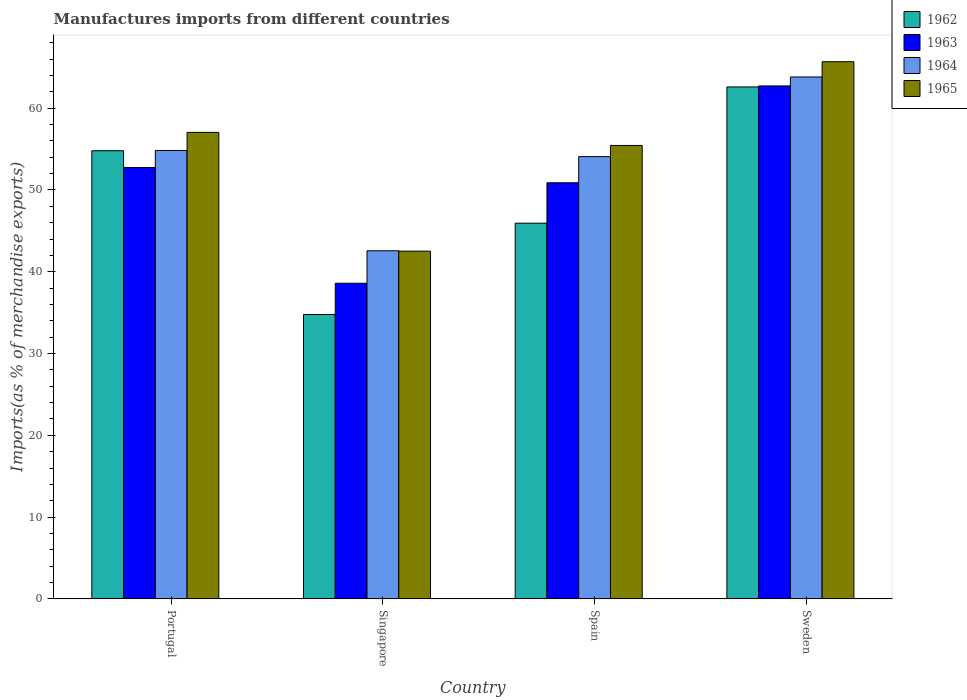How many bars are there on the 2nd tick from the left?
Make the answer very short. 4. How many bars are there on the 4th tick from the right?
Your answer should be very brief. 4. What is the label of the 4th group of bars from the left?
Your response must be concise. Sweden. What is the percentage of imports to different countries in 1965 in Spain?
Offer a very short reply. 55.44. Across all countries, what is the maximum percentage of imports to different countries in 1964?
Your answer should be compact. 63.82. Across all countries, what is the minimum percentage of imports to different countries in 1962?
Your answer should be compact. 34.77. In which country was the percentage of imports to different countries in 1963 minimum?
Make the answer very short. Singapore. What is the total percentage of imports to different countries in 1963 in the graph?
Make the answer very short. 204.95. What is the difference between the percentage of imports to different countries in 1964 in Portugal and that in Sweden?
Ensure brevity in your answer.  -8.99. What is the difference between the percentage of imports to different countries in 1963 in Singapore and the percentage of imports to different countries in 1962 in Spain?
Provide a short and direct response. -7.34. What is the average percentage of imports to different countries in 1962 per country?
Make the answer very short. 49.53. What is the difference between the percentage of imports to different countries of/in 1965 and percentage of imports to different countries of/in 1964 in Singapore?
Ensure brevity in your answer.  -0.04. In how many countries, is the percentage of imports to different countries in 1964 greater than 36 %?
Offer a terse response. 4. What is the ratio of the percentage of imports to different countries in 1963 in Singapore to that in Sweden?
Keep it short and to the point. 0.62. What is the difference between the highest and the second highest percentage of imports to different countries in 1962?
Provide a short and direct response. 8.86. What is the difference between the highest and the lowest percentage of imports to different countries in 1962?
Provide a short and direct response. 27.83. In how many countries, is the percentage of imports to different countries in 1964 greater than the average percentage of imports to different countries in 1964 taken over all countries?
Your response must be concise. 3. What does the 2nd bar from the left in Spain represents?
Offer a terse response. 1963. What does the 4th bar from the right in Singapore represents?
Provide a short and direct response. 1962. Is it the case that in every country, the sum of the percentage of imports to different countries in 1965 and percentage of imports to different countries in 1962 is greater than the percentage of imports to different countries in 1964?
Make the answer very short. Yes. How many bars are there?
Provide a short and direct response. 16. How many countries are there in the graph?
Keep it short and to the point. 4. Where does the legend appear in the graph?
Your response must be concise. Top right. How are the legend labels stacked?
Provide a succinct answer. Vertical. What is the title of the graph?
Provide a succinct answer. Manufactures imports from different countries. Does "1993" appear as one of the legend labels in the graph?
Your answer should be very brief. No. What is the label or title of the X-axis?
Keep it short and to the point. Country. What is the label or title of the Y-axis?
Make the answer very short. Imports(as % of merchandise exports). What is the Imports(as % of merchandise exports) in 1962 in Portugal?
Give a very brief answer. 54.8. What is the Imports(as % of merchandise exports) of 1963 in Portugal?
Offer a terse response. 52.75. What is the Imports(as % of merchandise exports) of 1964 in Portugal?
Make the answer very short. 54.83. What is the Imports(as % of merchandise exports) of 1965 in Portugal?
Give a very brief answer. 57.04. What is the Imports(as % of merchandise exports) in 1962 in Singapore?
Make the answer very short. 34.77. What is the Imports(as % of merchandise exports) in 1963 in Singapore?
Keep it short and to the point. 38.6. What is the Imports(as % of merchandise exports) of 1964 in Singapore?
Provide a short and direct response. 42.56. What is the Imports(as % of merchandise exports) in 1965 in Singapore?
Make the answer very short. 42.52. What is the Imports(as % of merchandise exports) of 1962 in Spain?
Provide a succinct answer. 45.94. What is the Imports(as % of merchandise exports) of 1963 in Spain?
Provide a short and direct response. 50.88. What is the Imports(as % of merchandise exports) in 1964 in Spain?
Give a very brief answer. 54.08. What is the Imports(as % of merchandise exports) in 1965 in Spain?
Offer a very short reply. 55.44. What is the Imports(as % of merchandise exports) in 1962 in Sweden?
Your answer should be compact. 62.6. What is the Imports(as % of merchandise exports) in 1963 in Sweden?
Provide a short and direct response. 62.72. What is the Imports(as % of merchandise exports) in 1964 in Sweden?
Your response must be concise. 63.82. What is the Imports(as % of merchandise exports) in 1965 in Sweden?
Your answer should be compact. 65.68. Across all countries, what is the maximum Imports(as % of merchandise exports) of 1962?
Your answer should be very brief. 62.6. Across all countries, what is the maximum Imports(as % of merchandise exports) in 1963?
Offer a very short reply. 62.72. Across all countries, what is the maximum Imports(as % of merchandise exports) in 1964?
Your response must be concise. 63.82. Across all countries, what is the maximum Imports(as % of merchandise exports) of 1965?
Ensure brevity in your answer.  65.68. Across all countries, what is the minimum Imports(as % of merchandise exports) of 1962?
Ensure brevity in your answer.  34.77. Across all countries, what is the minimum Imports(as % of merchandise exports) of 1963?
Your response must be concise. 38.6. Across all countries, what is the minimum Imports(as % of merchandise exports) of 1964?
Ensure brevity in your answer.  42.56. Across all countries, what is the minimum Imports(as % of merchandise exports) in 1965?
Give a very brief answer. 42.52. What is the total Imports(as % of merchandise exports) of 1962 in the graph?
Keep it short and to the point. 198.11. What is the total Imports(as % of merchandise exports) in 1963 in the graph?
Your answer should be compact. 204.95. What is the total Imports(as % of merchandise exports) of 1964 in the graph?
Offer a very short reply. 215.29. What is the total Imports(as % of merchandise exports) of 1965 in the graph?
Give a very brief answer. 220.69. What is the difference between the Imports(as % of merchandise exports) in 1962 in Portugal and that in Singapore?
Your response must be concise. 20.03. What is the difference between the Imports(as % of merchandise exports) of 1963 in Portugal and that in Singapore?
Provide a short and direct response. 14.16. What is the difference between the Imports(as % of merchandise exports) in 1964 in Portugal and that in Singapore?
Make the answer very short. 12.27. What is the difference between the Imports(as % of merchandise exports) in 1965 in Portugal and that in Singapore?
Your response must be concise. 14.52. What is the difference between the Imports(as % of merchandise exports) of 1962 in Portugal and that in Spain?
Provide a short and direct response. 8.86. What is the difference between the Imports(as % of merchandise exports) in 1963 in Portugal and that in Spain?
Give a very brief answer. 1.87. What is the difference between the Imports(as % of merchandise exports) in 1964 in Portugal and that in Spain?
Your answer should be very brief. 0.75. What is the difference between the Imports(as % of merchandise exports) in 1965 in Portugal and that in Spain?
Give a very brief answer. 1.6. What is the difference between the Imports(as % of merchandise exports) in 1962 in Portugal and that in Sweden?
Provide a succinct answer. -7.8. What is the difference between the Imports(as % of merchandise exports) in 1963 in Portugal and that in Sweden?
Ensure brevity in your answer.  -9.97. What is the difference between the Imports(as % of merchandise exports) in 1964 in Portugal and that in Sweden?
Your response must be concise. -8.99. What is the difference between the Imports(as % of merchandise exports) of 1965 in Portugal and that in Sweden?
Your answer should be very brief. -8.64. What is the difference between the Imports(as % of merchandise exports) of 1962 in Singapore and that in Spain?
Provide a short and direct response. -11.17. What is the difference between the Imports(as % of merchandise exports) in 1963 in Singapore and that in Spain?
Offer a terse response. -12.29. What is the difference between the Imports(as % of merchandise exports) of 1964 in Singapore and that in Spain?
Your response must be concise. -11.51. What is the difference between the Imports(as % of merchandise exports) of 1965 in Singapore and that in Spain?
Offer a terse response. -12.92. What is the difference between the Imports(as % of merchandise exports) in 1962 in Singapore and that in Sweden?
Keep it short and to the point. -27.83. What is the difference between the Imports(as % of merchandise exports) in 1963 in Singapore and that in Sweden?
Offer a very short reply. -24.13. What is the difference between the Imports(as % of merchandise exports) of 1964 in Singapore and that in Sweden?
Offer a very short reply. -21.25. What is the difference between the Imports(as % of merchandise exports) in 1965 in Singapore and that in Sweden?
Provide a succinct answer. -23.16. What is the difference between the Imports(as % of merchandise exports) in 1962 in Spain and that in Sweden?
Give a very brief answer. -16.66. What is the difference between the Imports(as % of merchandise exports) in 1963 in Spain and that in Sweden?
Provide a short and direct response. -11.84. What is the difference between the Imports(as % of merchandise exports) of 1964 in Spain and that in Sweden?
Offer a very short reply. -9.74. What is the difference between the Imports(as % of merchandise exports) in 1965 in Spain and that in Sweden?
Your answer should be compact. -10.24. What is the difference between the Imports(as % of merchandise exports) in 1962 in Portugal and the Imports(as % of merchandise exports) in 1963 in Singapore?
Offer a very short reply. 16.2. What is the difference between the Imports(as % of merchandise exports) in 1962 in Portugal and the Imports(as % of merchandise exports) in 1964 in Singapore?
Provide a succinct answer. 12.23. What is the difference between the Imports(as % of merchandise exports) of 1962 in Portugal and the Imports(as % of merchandise exports) of 1965 in Singapore?
Provide a succinct answer. 12.28. What is the difference between the Imports(as % of merchandise exports) of 1963 in Portugal and the Imports(as % of merchandise exports) of 1964 in Singapore?
Provide a succinct answer. 10.19. What is the difference between the Imports(as % of merchandise exports) in 1963 in Portugal and the Imports(as % of merchandise exports) in 1965 in Singapore?
Offer a very short reply. 10.23. What is the difference between the Imports(as % of merchandise exports) in 1964 in Portugal and the Imports(as % of merchandise exports) in 1965 in Singapore?
Offer a very short reply. 12.31. What is the difference between the Imports(as % of merchandise exports) of 1962 in Portugal and the Imports(as % of merchandise exports) of 1963 in Spain?
Make the answer very short. 3.92. What is the difference between the Imports(as % of merchandise exports) of 1962 in Portugal and the Imports(as % of merchandise exports) of 1964 in Spain?
Give a very brief answer. 0.72. What is the difference between the Imports(as % of merchandise exports) of 1962 in Portugal and the Imports(as % of merchandise exports) of 1965 in Spain?
Provide a succinct answer. -0.65. What is the difference between the Imports(as % of merchandise exports) in 1963 in Portugal and the Imports(as % of merchandise exports) in 1964 in Spain?
Your answer should be compact. -1.33. What is the difference between the Imports(as % of merchandise exports) of 1963 in Portugal and the Imports(as % of merchandise exports) of 1965 in Spain?
Provide a succinct answer. -2.69. What is the difference between the Imports(as % of merchandise exports) of 1964 in Portugal and the Imports(as % of merchandise exports) of 1965 in Spain?
Make the answer very short. -0.61. What is the difference between the Imports(as % of merchandise exports) in 1962 in Portugal and the Imports(as % of merchandise exports) in 1963 in Sweden?
Your answer should be compact. -7.92. What is the difference between the Imports(as % of merchandise exports) of 1962 in Portugal and the Imports(as % of merchandise exports) of 1964 in Sweden?
Ensure brevity in your answer.  -9.02. What is the difference between the Imports(as % of merchandise exports) of 1962 in Portugal and the Imports(as % of merchandise exports) of 1965 in Sweden?
Your answer should be very brief. -10.88. What is the difference between the Imports(as % of merchandise exports) in 1963 in Portugal and the Imports(as % of merchandise exports) in 1964 in Sweden?
Your response must be concise. -11.07. What is the difference between the Imports(as % of merchandise exports) of 1963 in Portugal and the Imports(as % of merchandise exports) of 1965 in Sweden?
Make the answer very short. -12.93. What is the difference between the Imports(as % of merchandise exports) of 1964 in Portugal and the Imports(as % of merchandise exports) of 1965 in Sweden?
Your response must be concise. -10.85. What is the difference between the Imports(as % of merchandise exports) of 1962 in Singapore and the Imports(as % of merchandise exports) of 1963 in Spain?
Your answer should be very brief. -16.11. What is the difference between the Imports(as % of merchandise exports) of 1962 in Singapore and the Imports(as % of merchandise exports) of 1964 in Spain?
Give a very brief answer. -19.31. What is the difference between the Imports(as % of merchandise exports) in 1962 in Singapore and the Imports(as % of merchandise exports) in 1965 in Spain?
Provide a short and direct response. -20.68. What is the difference between the Imports(as % of merchandise exports) of 1963 in Singapore and the Imports(as % of merchandise exports) of 1964 in Spain?
Ensure brevity in your answer.  -15.48. What is the difference between the Imports(as % of merchandise exports) of 1963 in Singapore and the Imports(as % of merchandise exports) of 1965 in Spain?
Provide a short and direct response. -16.85. What is the difference between the Imports(as % of merchandise exports) of 1964 in Singapore and the Imports(as % of merchandise exports) of 1965 in Spain?
Ensure brevity in your answer.  -12.88. What is the difference between the Imports(as % of merchandise exports) in 1962 in Singapore and the Imports(as % of merchandise exports) in 1963 in Sweden?
Give a very brief answer. -27.95. What is the difference between the Imports(as % of merchandise exports) in 1962 in Singapore and the Imports(as % of merchandise exports) in 1964 in Sweden?
Offer a terse response. -29.05. What is the difference between the Imports(as % of merchandise exports) in 1962 in Singapore and the Imports(as % of merchandise exports) in 1965 in Sweden?
Keep it short and to the point. -30.91. What is the difference between the Imports(as % of merchandise exports) in 1963 in Singapore and the Imports(as % of merchandise exports) in 1964 in Sweden?
Provide a succinct answer. -25.22. What is the difference between the Imports(as % of merchandise exports) in 1963 in Singapore and the Imports(as % of merchandise exports) in 1965 in Sweden?
Give a very brief answer. -27.09. What is the difference between the Imports(as % of merchandise exports) of 1964 in Singapore and the Imports(as % of merchandise exports) of 1965 in Sweden?
Offer a very short reply. -23.12. What is the difference between the Imports(as % of merchandise exports) in 1962 in Spain and the Imports(as % of merchandise exports) in 1963 in Sweden?
Make the answer very short. -16.78. What is the difference between the Imports(as % of merchandise exports) of 1962 in Spain and the Imports(as % of merchandise exports) of 1964 in Sweden?
Give a very brief answer. -17.88. What is the difference between the Imports(as % of merchandise exports) in 1962 in Spain and the Imports(as % of merchandise exports) in 1965 in Sweden?
Give a very brief answer. -19.74. What is the difference between the Imports(as % of merchandise exports) of 1963 in Spain and the Imports(as % of merchandise exports) of 1964 in Sweden?
Offer a very short reply. -12.94. What is the difference between the Imports(as % of merchandise exports) of 1963 in Spain and the Imports(as % of merchandise exports) of 1965 in Sweden?
Make the answer very short. -14.8. What is the difference between the Imports(as % of merchandise exports) of 1964 in Spain and the Imports(as % of merchandise exports) of 1965 in Sweden?
Make the answer very short. -11.6. What is the average Imports(as % of merchandise exports) of 1962 per country?
Ensure brevity in your answer.  49.53. What is the average Imports(as % of merchandise exports) in 1963 per country?
Your answer should be very brief. 51.24. What is the average Imports(as % of merchandise exports) of 1964 per country?
Make the answer very short. 53.82. What is the average Imports(as % of merchandise exports) of 1965 per country?
Give a very brief answer. 55.17. What is the difference between the Imports(as % of merchandise exports) in 1962 and Imports(as % of merchandise exports) in 1963 in Portugal?
Give a very brief answer. 2.05. What is the difference between the Imports(as % of merchandise exports) in 1962 and Imports(as % of merchandise exports) in 1964 in Portugal?
Your answer should be compact. -0.03. What is the difference between the Imports(as % of merchandise exports) of 1962 and Imports(as % of merchandise exports) of 1965 in Portugal?
Your answer should be very brief. -2.24. What is the difference between the Imports(as % of merchandise exports) of 1963 and Imports(as % of merchandise exports) of 1964 in Portugal?
Provide a succinct answer. -2.08. What is the difference between the Imports(as % of merchandise exports) in 1963 and Imports(as % of merchandise exports) in 1965 in Portugal?
Your response must be concise. -4.29. What is the difference between the Imports(as % of merchandise exports) in 1964 and Imports(as % of merchandise exports) in 1965 in Portugal?
Keep it short and to the point. -2.21. What is the difference between the Imports(as % of merchandise exports) in 1962 and Imports(as % of merchandise exports) in 1963 in Singapore?
Keep it short and to the point. -3.83. What is the difference between the Imports(as % of merchandise exports) in 1962 and Imports(as % of merchandise exports) in 1964 in Singapore?
Provide a succinct answer. -7.8. What is the difference between the Imports(as % of merchandise exports) in 1962 and Imports(as % of merchandise exports) in 1965 in Singapore?
Provide a succinct answer. -7.75. What is the difference between the Imports(as % of merchandise exports) of 1963 and Imports(as % of merchandise exports) of 1964 in Singapore?
Ensure brevity in your answer.  -3.97. What is the difference between the Imports(as % of merchandise exports) in 1963 and Imports(as % of merchandise exports) in 1965 in Singapore?
Your answer should be compact. -3.93. What is the difference between the Imports(as % of merchandise exports) in 1964 and Imports(as % of merchandise exports) in 1965 in Singapore?
Give a very brief answer. 0.04. What is the difference between the Imports(as % of merchandise exports) in 1962 and Imports(as % of merchandise exports) in 1963 in Spain?
Offer a terse response. -4.94. What is the difference between the Imports(as % of merchandise exports) of 1962 and Imports(as % of merchandise exports) of 1964 in Spain?
Ensure brevity in your answer.  -8.14. What is the difference between the Imports(as % of merchandise exports) in 1962 and Imports(as % of merchandise exports) in 1965 in Spain?
Provide a succinct answer. -9.51. What is the difference between the Imports(as % of merchandise exports) of 1963 and Imports(as % of merchandise exports) of 1964 in Spain?
Your answer should be compact. -3.2. What is the difference between the Imports(as % of merchandise exports) in 1963 and Imports(as % of merchandise exports) in 1965 in Spain?
Your answer should be compact. -4.56. What is the difference between the Imports(as % of merchandise exports) in 1964 and Imports(as % of merchandise exports) in 1965 in Spain?
Give a very brief answer. -1.37. What is the difference between the Imports(as % of merchandise exports) of 1962 and Imports(as % of merchandise exports) of 1963 in Sweden?
Provide a succinct answer. -0.12. What is the difference between the Imports(as % of merchandise exports) of 1962 and Imports(as % of merchandise exports) of 1964 in Sweden?
Offer a very short reply. -1.22. What is the difference between the Imports(as % of merchandise exports) in 1962 and Imports(as % of merchandise exports) in 1965 in Sweden?
Offer a very short reply. -3.08. What is the difference between the Imports(as % of merchandise exports) of 1963 and Imports(as % of merchandise exports) of 1964 in Sweden?
Offer a very short reply. -1.09. What is the difference between the Imports(as % of merchandise exports) of 1963 and Imports(as % of merchandise exports) of 1965 in Sweden?
Give a very brief answer. -2.96. What is the difference between the Imports(as % of merchandise exports) of 1964 and Imports(as % of merchandise exports) of 1965 in Sweden?
Provide a short and direct response. -1.87. What is the ratio of the Imports(as % of merchandise exports) of 1962 in Portugal to that in Singapore?
Keep it short and to the point. 1.58. What is the ratio of the Imports(as % of merchandise exports) of 1963 in Portugal to that in Singapore?
Provide a short and direct response. 1.37. What is the ratio of the Imports(as % of merchandise exports) of 1964 in Portugal to that in Singapore?
Ensure brevity in your answer.  1.29. What is the ratio of the Imports(as % of merchandise exports) of 1965 in Portugal to that in Singapore?
Give a very brief answer. 1.34. What is the ratio of the Imports(as % of merchandise exports) in 1962 in Portugal to that in Spain?
Ensure brevity in your answer.  1.19. What is the ratio of the Imports(as % of merchandise exports) of 1963 in Portugal to that in Spain?
Provide a succinct answer. 1.04. What is the ratio of the Imports(as % of merchandise exports) in 1964 in Portugal to that in Spain?
Your response must be concise. 1.01. What is the ratio of the Imports(as % of merchandise exports) of 1965 in Portugal to that in Spain?
Offer a terse response. 1.03. What is the ratio of the Imports(as % of merchandise exports) in 1962 in Portugal to that in Sweden?
Ensure brevity in your answer.  0.88. What is the ratio of the Imports(as % of merchandise exports) in 1963 in Portugal to that in Sweden?
Your answer should be very brief. 0.84. What is the ratio of the Imports(as % of merchandise exports) of 1964 in Portugal to that in Sweden?
Provide a short and direct response. 0.86. What is the ratio of the Imports(as % of merchandise exports) in 1965 in Portugal to that in Sweden?
Offer a very short reply. 0.87. What is the ratio of the Imports(as % of merchandise exports) in 1962 in Singapore to that in Spain?
Make the answer very short. 0.76. What is the ratio of the Imports(as % of merchandise exports) in 1963 in Singapore to that in Spain?
Provide a short and direct response. 0.76. What is the ratio of the Imports(as % of merchandise exports) in 1964 in Singapore to that in Spain?
Ensure brevity in your answer.  0.79. What is the ratio of the Imports(as % of merchandise exports) in 1965 in Singapore to that in Spain?
Offer a very short reply. 0.77. What is the ratio of the Imports(as % of merchandise exports) of 1962 in Singapore to that in Sweden?
Give a very brief answer. 0.56. What is the ratio of the Imports(as % of merchandise exports) in 1963 in Singapore to that in Sweden?
Ensure brevity in your answer.  0.62. What is the ratio of the Imports(as % of merchandise exports) of 1964 in Singapore to that in Sweden?
Provide a succinct answer. 0.67. What is the ratio of the Imports(as % of merchandise exports) in 1965 in Singapore to that in Sweden?
Your answer should be compact. 0.65. What is the ratio of the Imports(as % of merchandise exports) of 1962 in Spain to that in Sweden?
Give a very brief answer. 0.73. What is the ratio of the Imports(as % of merchandise exports) in 1963 in Spain to that in Sweden?
Give a very brief answer. 0.81. What is the ratio of the Imports(as % of merchandise exports) in 1964 in Spain to that in Sweden?
Your answer should be compact. 0.85. What is the ratio of the Imports(as % of merchandise exports) in 1965 in Spain to that in Sweden?
Ensure brevity in your answer.  0.84. What is the difference between the highest and the second highest Imports(as % of merchandise exports) in 1962?
Your answer should be very brief. 7.8. What is the difference between the highest and the second highest Imports(as % of merchandise exports) in 1963?
Offer a terse response. 9.97. What is the difference between the highest and the second highest Imports(as % of merchandise exports) of 1964?
Your answer should be compact. 8.99. What is the difference between the highest and the second highest Imports(as % of merchandise exports) of 1965?
Provide a short and direct response. 8.64. What is the difference between the highest and the lowest Imports(as % of merchandise exports) in 1962?
Your answer should be compact. 27.83. What is the difference between the highest and the lowest Imports(as % of merchandise exports) in 1963?
Your response must be concise. 24.13. What is the difference between the highest and the lowest Imports(as % of merchandise exports) in 1964?
Provide a short and direct response. 21.25. What is the difference between the highest and the lowest Imports(as % of merchandise exports) in 1965?
Your answer should be very brief. 23.16. 